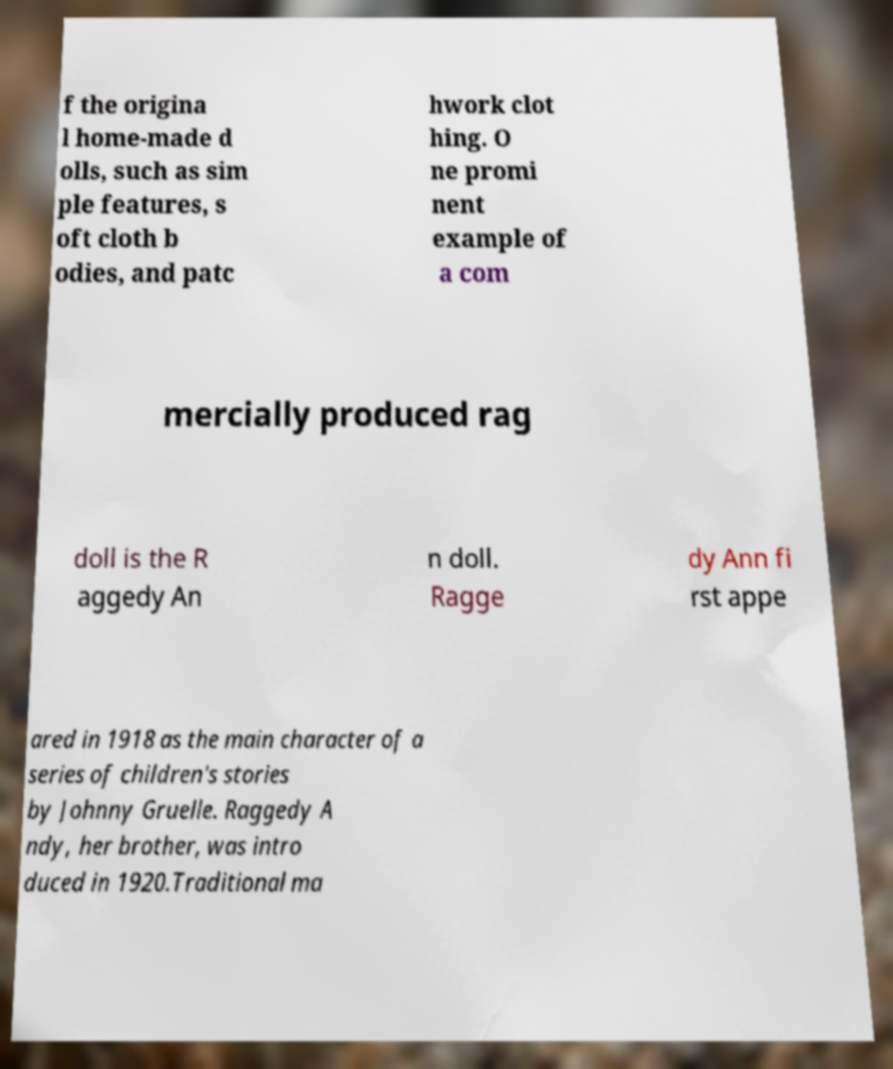Could you extract and type out the text from this image? f the origina l home-made d olls, such as sim ple features, s oft cloth b odies, and patc hwork clot hing. O ne promi nent example of a com mercially produced rag doll is the R aggedy An n doll. Ragge dy Ann fi rst appe ared in 1918 as the main character of a series of children's stories by Johnny Gruelle. Raggedy A ndy, her brother, was intro duced in 1920.Traditional ma 